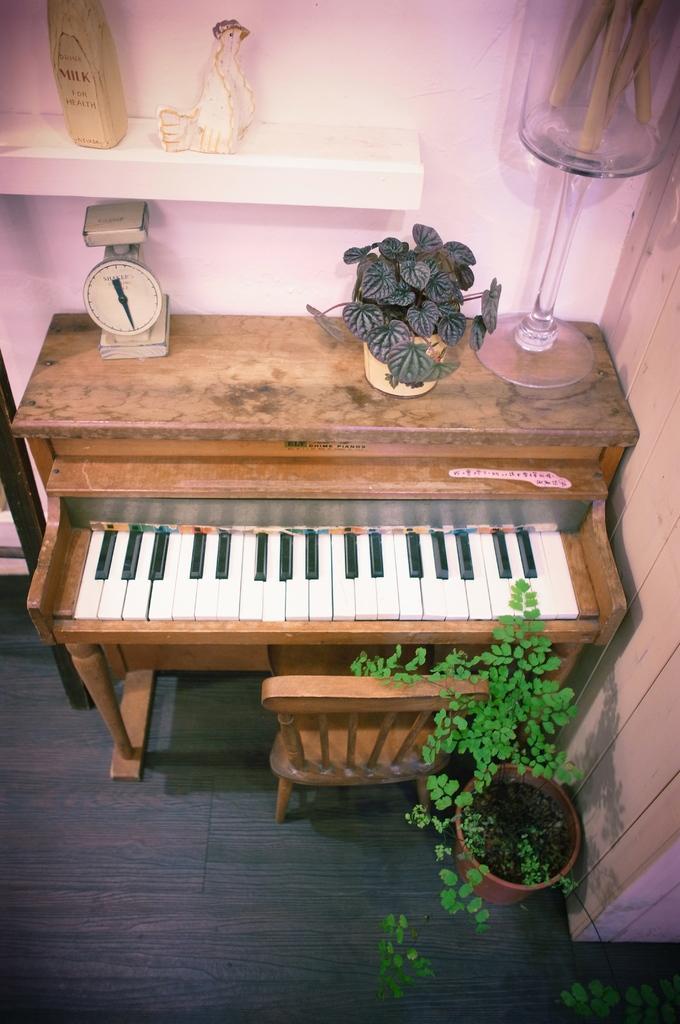How would you summarize this image in a sentence or two? In this picture we see a musical instrument piano and a chair and a small plant and few toys 